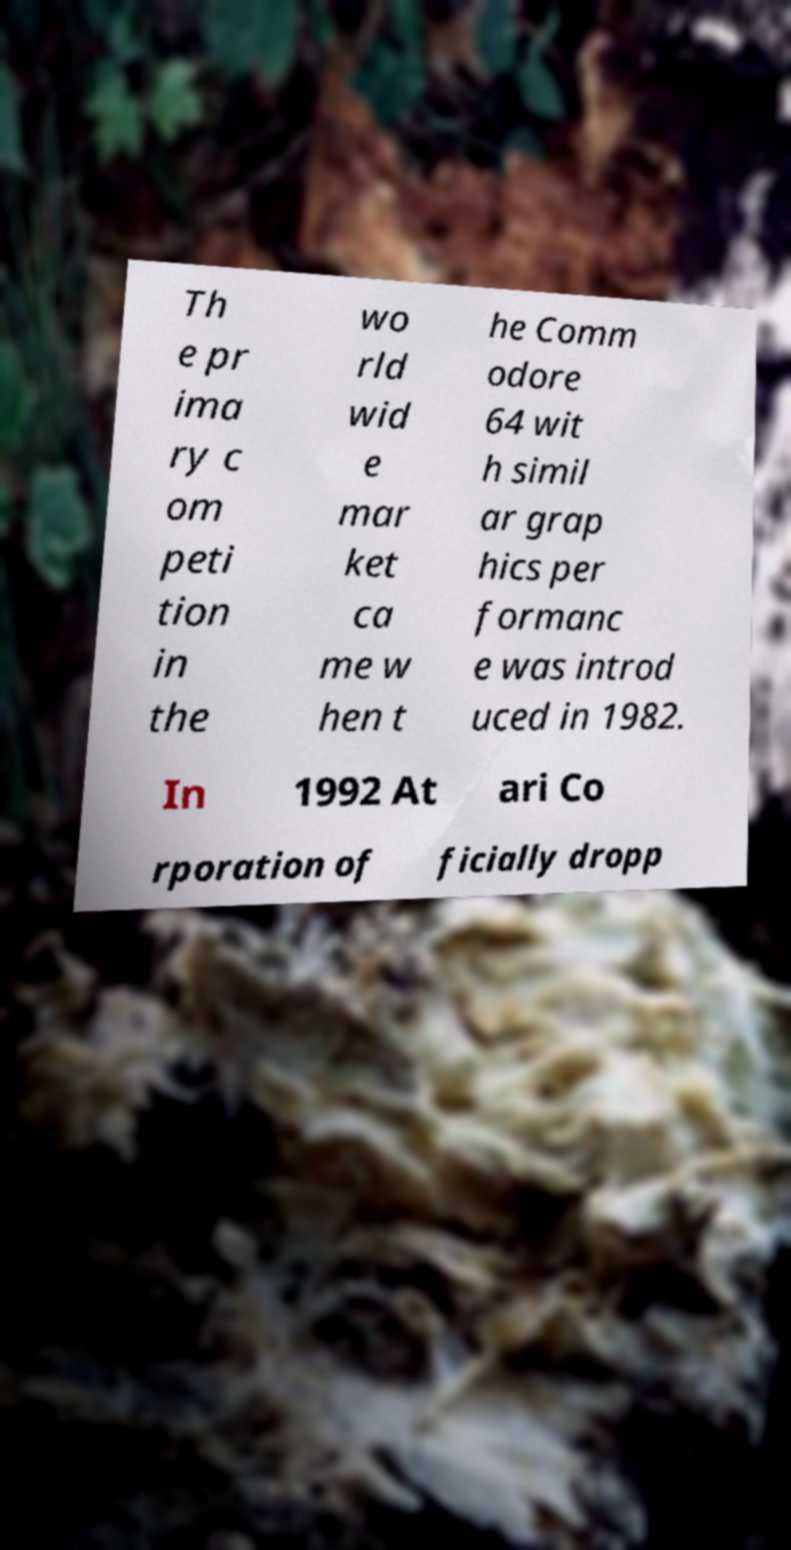For documentation purposes, I need the text within this image transcribed. Could you provide that? Th e pr ima ry c om peti tion in the wo rld wid e mar ket ca me w hen t he Comm odore 64 wit h simil ar grap hics per formanc e was introd uced in 1982. In 1992 At ari Co rporation of ficially dropp 